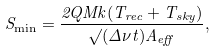Convert formula to latex. <formula><loc_0><loc_0><loc_500><loc_500>S _ { \min } = \frac { 2 Q M k ( T _ { r e c } + T _ { s k y } ) } { \surd ( \Delta \nu t ) A _ { e f f } } ,</formula> 